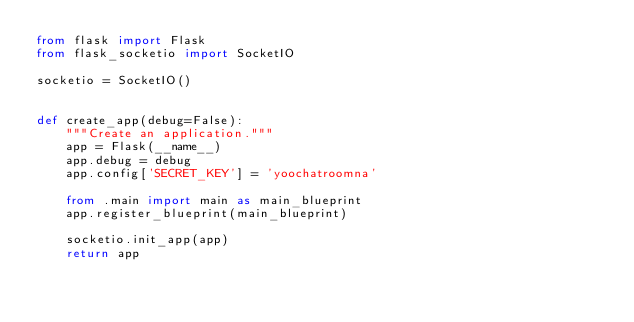Convert code to text. <code><loc_0><loc_0><loc_500><loc_500><_Python_>from flask import Flask
from flask_socketio import SocketIO

socketio = SocketIO()


def create_app(debug=False):
    """Create an application."""
    app = Flask(__name__)
    app.debug = debug
    app.config['SECRET_KEY'] = 'yoochatroomna'

    from .main import main as main_blueprint
    app.register_blueprint(main_blueprint)

    socketio.init_app(app)
    return app

</code> 